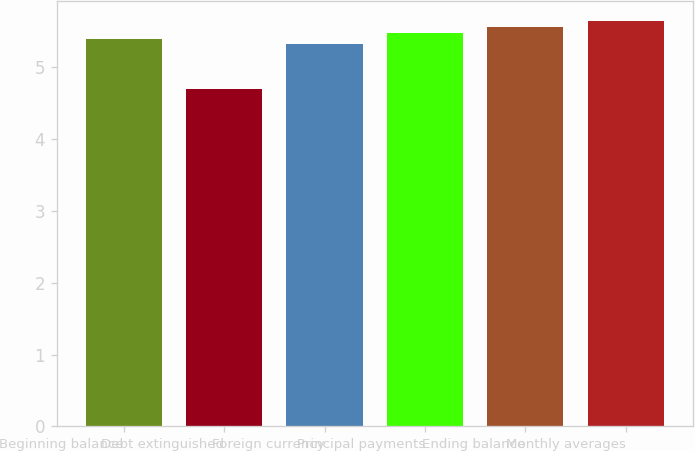Convert chart to OTSL. <chart><loc_0><loc_0><loc_500><loc_500><bar_chart><fcel>Beginning balance<fcel>Debt extinguished<fcel>Foreign currency<fcel>Principal payments<fcel>Ending balance<fcel>Monthly averages<nl><fcel>5.4<fcel>4.7<fcel>5.32<fcel>5.48<fcel>5.56<fcel>5.64<nl></chart> 